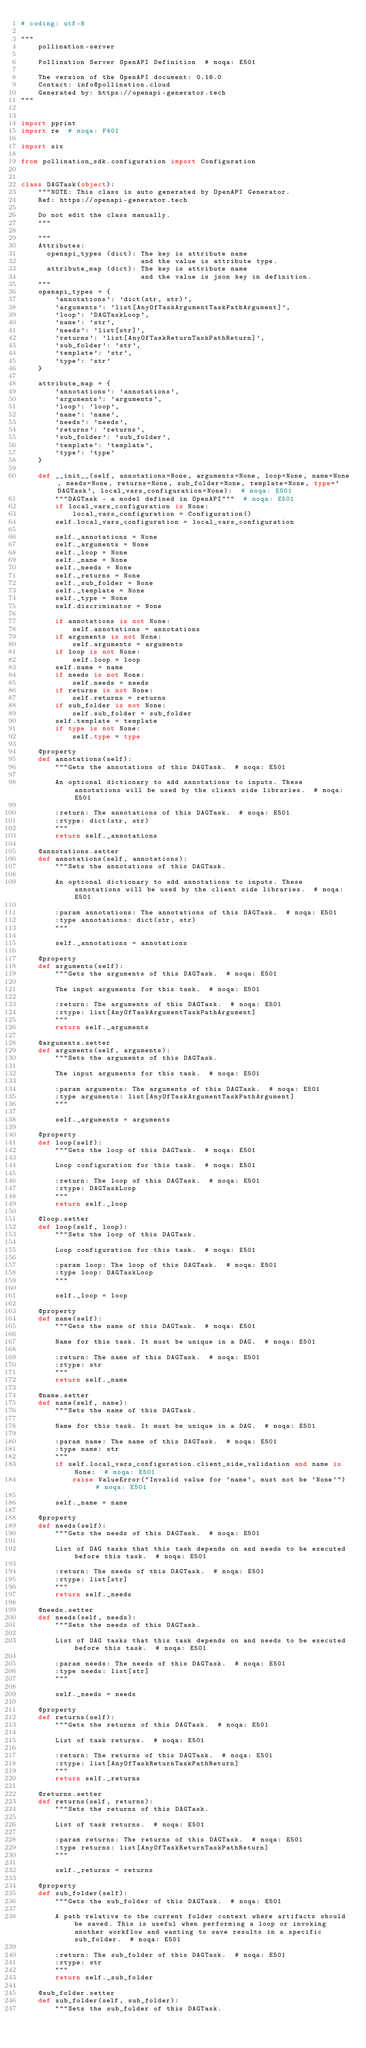Convert code to text. <code><loc_0><loc_0><loc_500><loc_500><_Python_># coding: utf-8

"""
    pollination-server

    Pollination Server OpenAPI Definition  # noqa: E501

    The version of the OpenAPI document: 0.16.0
    Contact: info@pollination.cloud
    Generated by: https://openapi-generator.tech
"""


import pprint
import re  # noqa: F401

import six

from pollination_sdk.configuration import Configuration


class DAGTask(object):
    """NOTE: This class is auto generated by OpenAPI Generator.
    Ref: https://openapi-generator.tech

    Do not edit the class manually.
    """

    """
    Attributes:
      openapi_types (dict): The key is attribute name
                            and the value is attribute type.
      attribute_map (dict): The key is attribute name
                            and the value is json key in definition.
    """
    openapi_types = {
        'annotations': 'dict(str, str)',
        'arguments': 'list[AnyOfTaskArgumentTaskPathArgument]',
        'loop': 'DAGTaskLoop',
        'name': 'str',
        'needs': 'list[str]',
        'returns': 'list[AnyOfTaskReturnTaskPathReturn]',
        'sub_folder': 'str',
        'template': 'str',
        'type': 'str'
    }

    attribute_map = {
        'annotations': 'annotations',
        'arguments': 'arguments',
        'loop': 'loop',
        'name': 'name',
        'needs': 'needs',
        'returns': 'returns',
        'sub_folder': 'sub_folder',
        'template': 'template',
        'type': 'type'
    }

    def __init__(self, annotations=None, arguments=None, loop=None, name=None, needs=None, returns=None, sub_folder=None, template=None, type='DAGTask', local_vars_configuration=None):  # noqa: E501
        """DAGTask - a model defined in OpenAPI"""  # noqa: E501
        if local_vars_configuration is None:
            local_vars_configuration = Configuration()
        self.local_vars_configuration = local_vars_configuration

        self._annotations = None
        self._arguments = None
        self._loop = None
        self._name = None
        self._needs = None
        self._returns = None
        self._sub_folder = None
        self._template = None
        self._type = None
        self.discriminator = None

        if annotations is not None:
            self.annotations = annotations
        if arguments is not None:
            self.arguments = arguments
        if loop is not None:
            self.loop = loop
        self.name = name
        if needs is not None:
            self.needs = needs
        if returns is not None:
            self.returns = returns
        if sub_folder is not None:
            self.sub_folder = sub_folder
        self.template = template
        if type is not None:
            self.type = type

    @property
    def annotations(self):
        """Gets the annotations of this DAGTask.  # noqa: E501

        An optional dictionary to add annotations to inputs. These annotations will be used by the client side libraries.  # noqa: E501

        :return: The annotations of this DAGTask.  # noqa: E501
        :rtype: dict(str, str)
        """
        return self._annotations

    @annotations.setter
    def annotations(self, annotations):
        """Sets the annotations of this DAGTask.

        An optional dictionary to add annotations to inputs. These annotations will be used by the client side libraries.  # noqa: E501

        :param annotations: The annotations of this DAGTask.  # noqa: E501
        :type annotations: dict(str, str)
        """

        self._annotations = annotations

    @property
    def arguments(self):
        """Gets the arguments of this DAGTask.  # noqa: E501

        The input arguments for this task.  # noqa: E501

        :return: The arguments of this DAGTask.  # noqa: E501
        :rtype: list[AnyOfTaskArgumentTaskPathArgument]
        """
        return self._arguments

    @arguments.setter
    def arguments(self, arguments):
        """Sets the arguments of this DAGTask.

        The input arguments for this task.  # noqa: E501

        :param arguments: The arguments of this DAGTask.  # noqa: E501
        :type arguments: list[AnyOfTaskArgumentTaskPathArgument]
        """

        self._arguments = arguments

    @property
    def loop(self):
        """Gets the loop of this DAGTask.  # noqa: E501

        Loop configuration for this task.  # noqa: E501

        :return: The loop of this DAGTask.  # noqa: E501
        :rtype: DAGTaskLoop
        """
        return self._loop

    @loop.setter
    def loop(self, loop):
        """Sets the loop of this DAGTask.

        Loop configuration for this task.  # noqa: E501

        :param loop: The loop of this DAGTask.  # noqa: E501
        :type loop: DAGTaskLoop
        """

        self._loop = loop

    @property
    def name(self):
        """Gets the name of this DAGTask.  # noqa: E501

        Name for this task. It must be unique in a DAG.  # noqa: E501

        :return: The name of this DAGTask.  # noqa: E501
        :rtype: str
        """
        return self._name

    @name.setter
    def name(self, name):
        """Sets the name of this DAGTask.

        Name for this task. It must be unique in a DAG.  # noqa: E501

        :param name: The name of this DAGTask.  # noqa: E501
        :type name: str
        """
        if self.local_vars_configuration.client_side_validation and name is None:  # noqa: E501
            raise ValueError("Invalid value for `name`, must not be `None`")  # noqa: E501

        self._name = name

    @property
    def needs(self):
        """Gets the needs of this DAGTask.  # noqa: E501

        List of DAG tasks that this task depends on and needs to be executed before this task.  # noqa: E501

        :return: The needs of this DAGTask.  # noqa: E501
        :rtype: list[str]
        """
        return self._needs

    @needs.setter
    def needs(self, needs):
        """Sets the needs of this DAGTask.

        List of DAG tasks that this task depends on and needs to be executed before this task.  # noqa: E501

        :param needs: The needs of this DAGTask.  # noqa: E501
        :type needs: list[str]
        """

        self._needs = needs

    @property
    def returns(self):
        """Gets the returns of this DAGTask.  # noqa: E501

        List of task returns.  # noqa: E501

        :return: The returns of this DAGTask.  # noqa: E501
        :rtype: list[AnyOfTaskReturnTaskPathReturn]
        """
        return self._returns

    @returns.setter
    def returns(self, returns):
        """Sets the returns of this DAGTask.

        List of task returns.  # noqa: E501

        :param returns: The returns of this DAGTask.  # noqa: E501
        :type returns: list[AnyOfTaskReturnTaskPathReturn]
        """

        self._returns = returns

    @property
    def sub_folder(self):
        """Gets the sub_folder of this DAGTask.  # noqa: E501

        A path relative to the current folder context where artifacts should be saved. This is useful when performing a loop or invoking another workflow and wanting to save results in a specific sub_folder.  # noqa: E501

        :return: The sub_folder of this DAGTask.  # noqa: E501
        :rtype: str
        """
        return self._sub_folder

    @sub_folder.setter
    def sub_folder(self, sub_folder):
        """Sets the sub_folder of this DAGTask.
</code> 